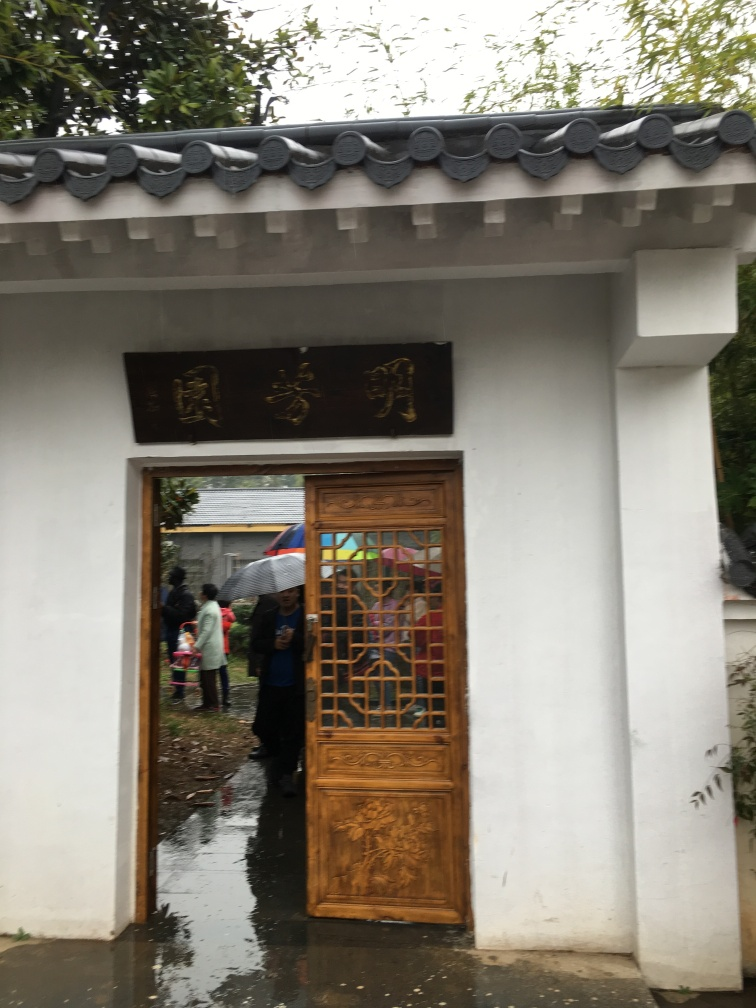What cultural significance does this type of architecture have? This architecture, with its tiled rooftop and traditional wooden door, reflects East Asian, possibly Chinese, architectural style. It often indicates a place of historical or cultural importance, perhaps a temple or old residence. 